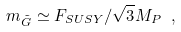<formula> <loc_0><loc_0><loc_500><loc_500>m _ { \tilde { G } } \simeq F _ { S U S Y } / \sqrt { 3 } M _ { P } \ ,</formula> 